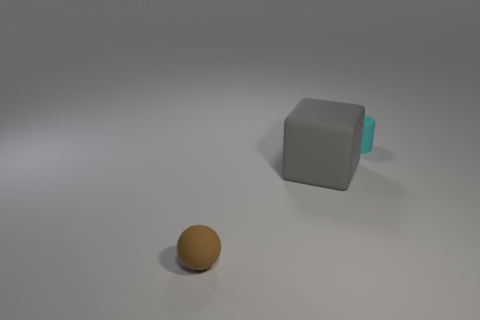What is the size of the brown sphere that is made of the same material as the big gray block?
Offer a terse response. Small. Are any small gray cylinders visible?
Your response must be concise. No. Are there any other things that are the same shape as the brown object?
Give a very brief answer. No. What shape is the small thing that is on the left side of the tiny object right of the object that is in front of the large matte block?
Offer a very short reply. Sphere. What shape is the big matte thing?
Offer a very short reply. Cube. What color is the tiny object that is to the right of the big gray rubber cube?
Give a very brief answer. Cyan. Do the rubber thing that is behind the gray cube and the gray rubber cube have the same size?
Your response must be concise. No. Is there anything else that is the same size as the cylinder?
Make the answer very short. Yes. Are there fewer rubber balls that are to the left of the gray object than things in front of the small cyan rubber cylinder?
Ensure brevity in your answer.  Yes. What number of gray objects are to the right of the gray object?
Keep it short and to the point. 0. 